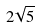Convert formula to latex. <formula><loc_0><loc_0><loc_500><loc_500>2 \sqrt { 5 }</formula> 